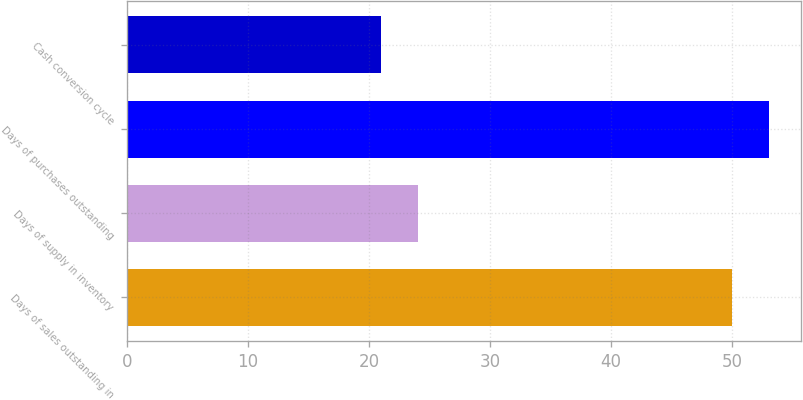<chart> <loc_0><loc_0><loc_500><loc_500><bar_chart><fcel>Days of sales outstanding in<fcel>Days of supply in inventory<fcel>Days of purchases outstanding<fcel>Cash conversion cycle<nl><fcel>50<fcel>24.1<fcel>53.1<fcel>21<nl></chart> 